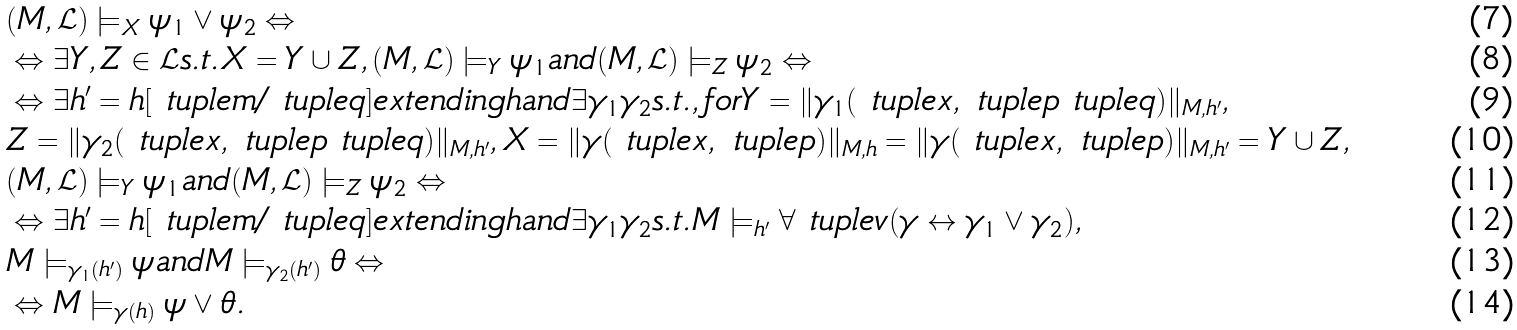<formula> <loc_0><loc_0><loc_500><loc_500>& ( M , \mathcal { L } ) \models _ { X } \psi _ { 1 } \vee \psi _ { 2 } \Leftrightarrow \\ & \Leftrightarrow \exists Y , Z \in \mathcal { L } s . t . X = Y \cup Z , ( M , \mathcal { L } ) \models _ { Y } \psi _ { 1 } a n d ( M , \mathcal { L } ) \models _ { Z } \psi _ { 2 } \Leftrightarrow \\ & \Leftrightarrow \exists h ^ { \prime } = h [ \ t u p l e m / \ t u p l e q ] e x t e n d i n g h a n d \exists \gamma _ { 1 } \gamma _ { 2 } s . t . , f o r Y = \| \gamma _ { 1 } ( \ t u p l e x , \ t u p l e p \ t u p l e q ) \| _ { M , h ^ { \prime } } , \\ & Z = \| \gamma _ { 2 } ( \ t u p l e x , \ t u p l e p \ t u p l e q ) \| _ { M , h ^ { \prime } } , X = \| \gamma ( \ t u p l e x , \ t u p l e p ) \| _ { M , h } = \| \gamma ( \ t u p l e x , \ t u p l e p ) \| _ { M , h ^ { \prime } } = Y \cup Z , \\ & ( M , \mathcal { L } ) \models _ { Y } \psi _ { 1 } a n d ( M , \mathcal { L } ) \models _ { Z } \psi _ { 2 } \Leftrightarrow \\ & \Leftrightarrow \exists h ^ { \prime } = h [ \ t u p l e m / \ t u p l e q ] e x t e n d i n g h a n d \exists \gamma _ { 1 } \gamma _ { 2 } s . t . M \models _ { h ^ { \prime } } \forall \ t u p l e v ( \gamma \leftrightarrow \gamma _ { 1 } \vee \gamma _ { 2 } ) , \\ & M \models _ { \gamma _ { 1 } ( h ^ { \prime } ) } \psi a n d M \models _ { \gamma _ { 2 } ( h ^ { \prime } ) } \theta \Leftrightarrow \\ & \Leftrightarrow M \models _ { \gamma ( h ) } \psi \vee \theta .</formula> 